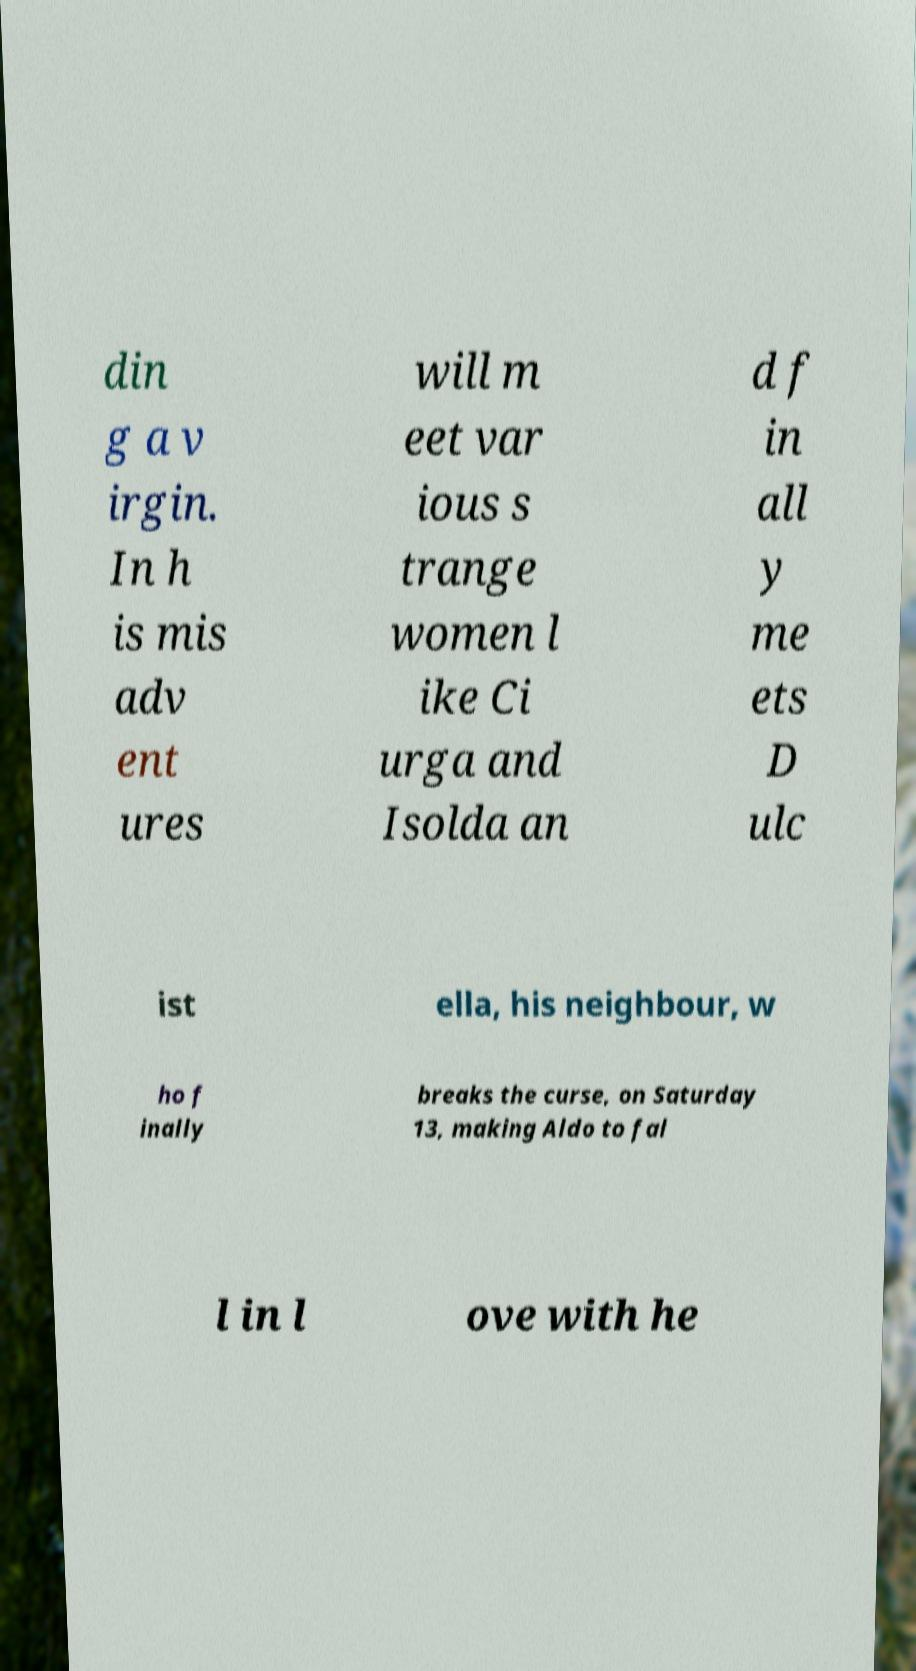Please read and relay the text visible in this image. What does it say? din g a v irgin. In h is mis adv ent ures will m eet var ious s trange women l ike Ci urga and Isolda an d f in all y me ets D ulc ist ella, his neighbour, w ho f inally breaks the curse, on Saturday 13, making Aldo to fal l in l ove with he 